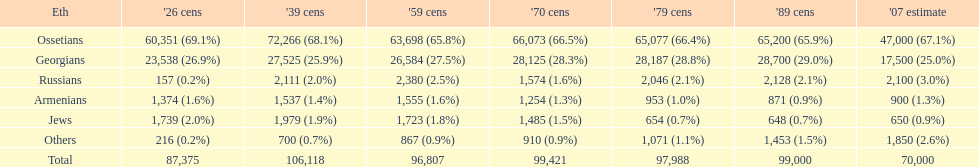How many russians lived in south ossetia in 1970? 1,574. Give me the full table as a dictionary. {'header': ['Eth', "'26 cens", "'39 cens", "'59 cens", "'70 cens", "'79 cens", "'89 cens", "'07 estimate"], 'rows': [['Ossetians', '60,351 (69.1%)', '72,266 (68.1%)', '63,698 (65.8%)', '66,073 (66.5%)', '65,077 (66.4%)', '65,200 (65.9%)', '47,000 (67.1%)'], ['Georgians', '23,538 (26.9%)', '27,525 (25.9%)', '26,584 (27.5%)', '28,125 (28.3%)', '28,187 (28.8%)', '28,700 (29.0%)', '17,500 (25.0%)'], ['Russians', '157 (0.2%)', '2,111 (2.0%)', '2,380 (2.5%)', '1,574 (1.6%)', '2,046 (2.1%)', '2,128 (2.1%)', '2,100 (3.0%)'], ['Armenians', '1,374 (1.6%)', '1,537 (1.4%)', '1,555 (1.6%)', '1,254 (1.3%)', '953 (1.0%)', '871 (0.9%)', '900 (1.3%)'], ['Jews', '1,739 (2.0%)', '1,979 (1.9%)', '1,723 (1.8%)', '1,485 (1.5%)', '654 (0.7%)', '648 (0.7%)', '650 (0.9%)'], ['Others', '216 (0.2%)', '700 (0.7%)', '867 (0.9%)', '910 (0.9%)', '1,071 (1.1%)', '1,453 (1.5%)', '1,850 (2.6%)'], ['Total', '87,375', '106,118', '96,807', '99,421', '97,988', '99,000', '70,000']]} 